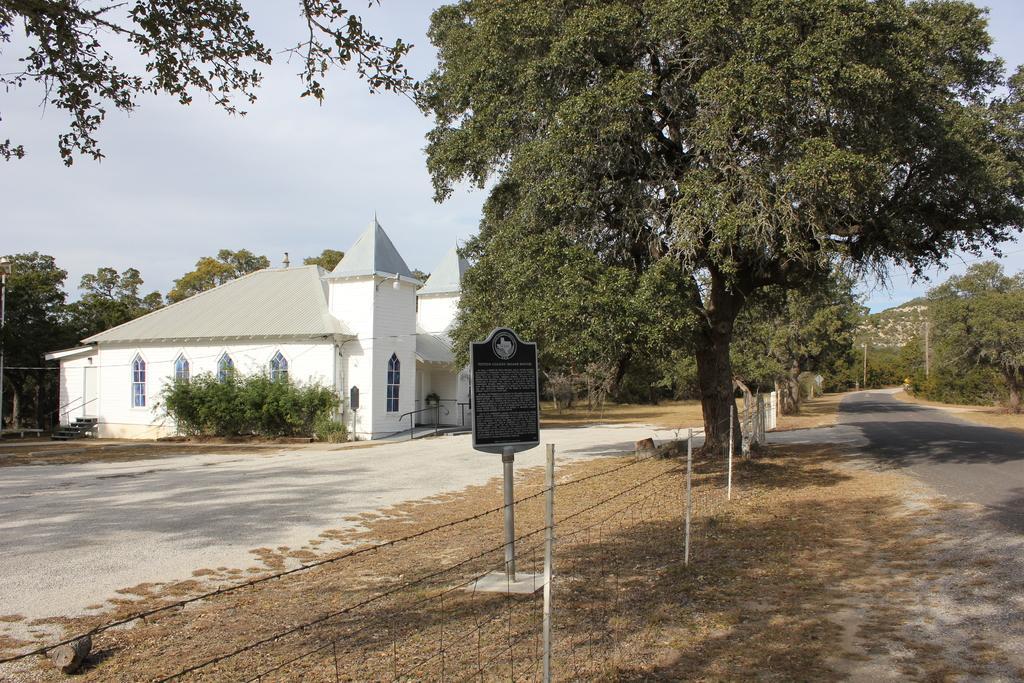Could you give a brief overview of what you see in this image? In this picture I can see an open land in front and I can see the fencing in the middle and I can see a board, on which there is something written. On the right side of this picture I can see the road. On the left side of this picture I can see a building and I can see number of trees. In the background I can see the clear sky. 